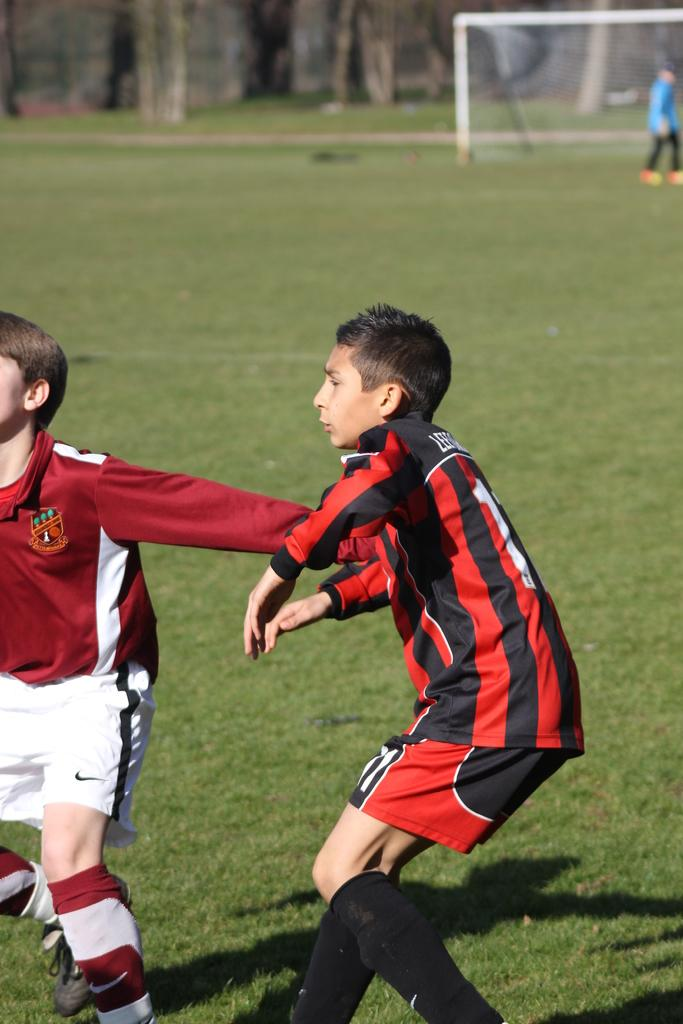What activity are the people in the image engaged in? The people in the image are playing a game. What can be seen in the background of the image? There is a net and grass visible in the background of the image. What type of vegetation is present in the background of the image? There are trees in the background of the image. What letters are the people playing with in the image? There are no letters present in the image; the people are playing a game that does not involve letters. 